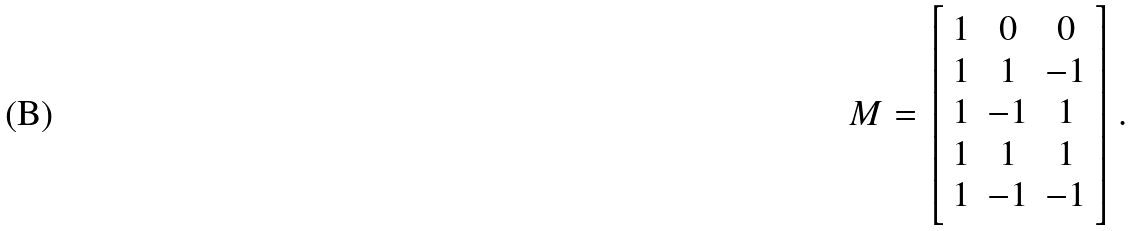<formula> <loc_0><loc_0><loc_500><loc_500>M = \left [ \begin{array} { c c c } 1 & 0 & 0 \\ 1 & 1 & - 1 \\ 1 & - 1 & 1 \\ 1 & 1 & 1 \\ 1 & - 1 & - 1 \end{array} \right ] .</formula> 